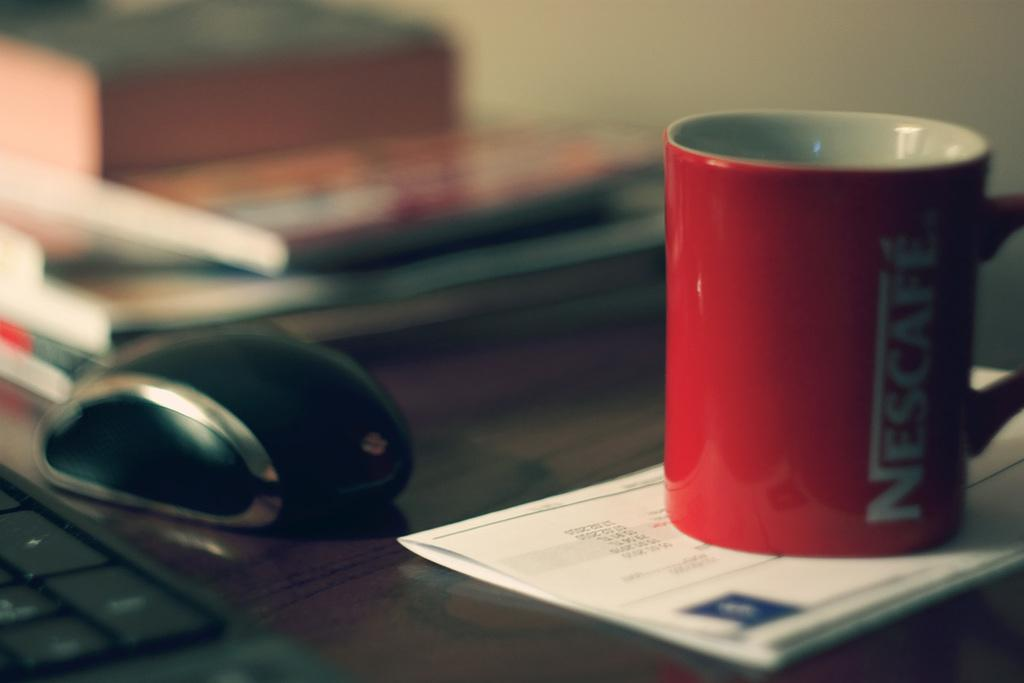<image>
Create a compact narrative representing the image presented. A red mug which has the word Nescafe on it in white. 